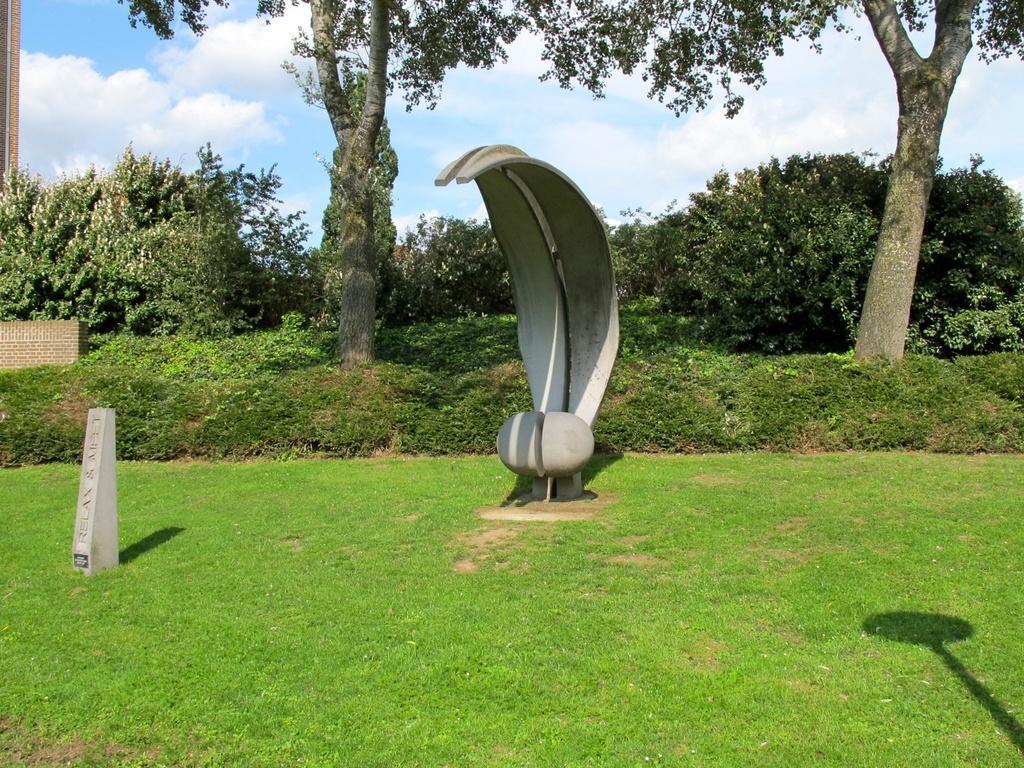Describe this image in one or two sentences. In the image there is a garden and there is a stone and a sculpture in the garden, in the background there are plants and trees. 